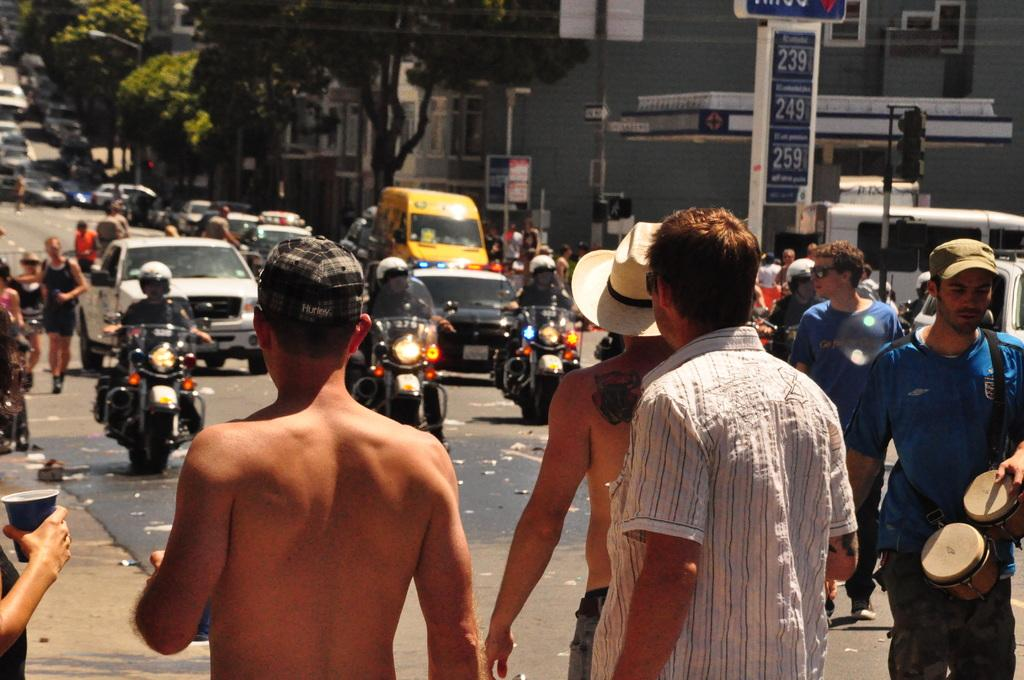What are the people in the image doing? The people in the image are moving on vehicles and standing on the road. What structures can be seen in the image? There are buildings visible in the image. What type of natural elements are present in the image? There are trees present in the image. What type of love story is unfolding between the boy and the trees in the image? There is no boy present in the image, and therefore no love story involving a boy can be observed. 